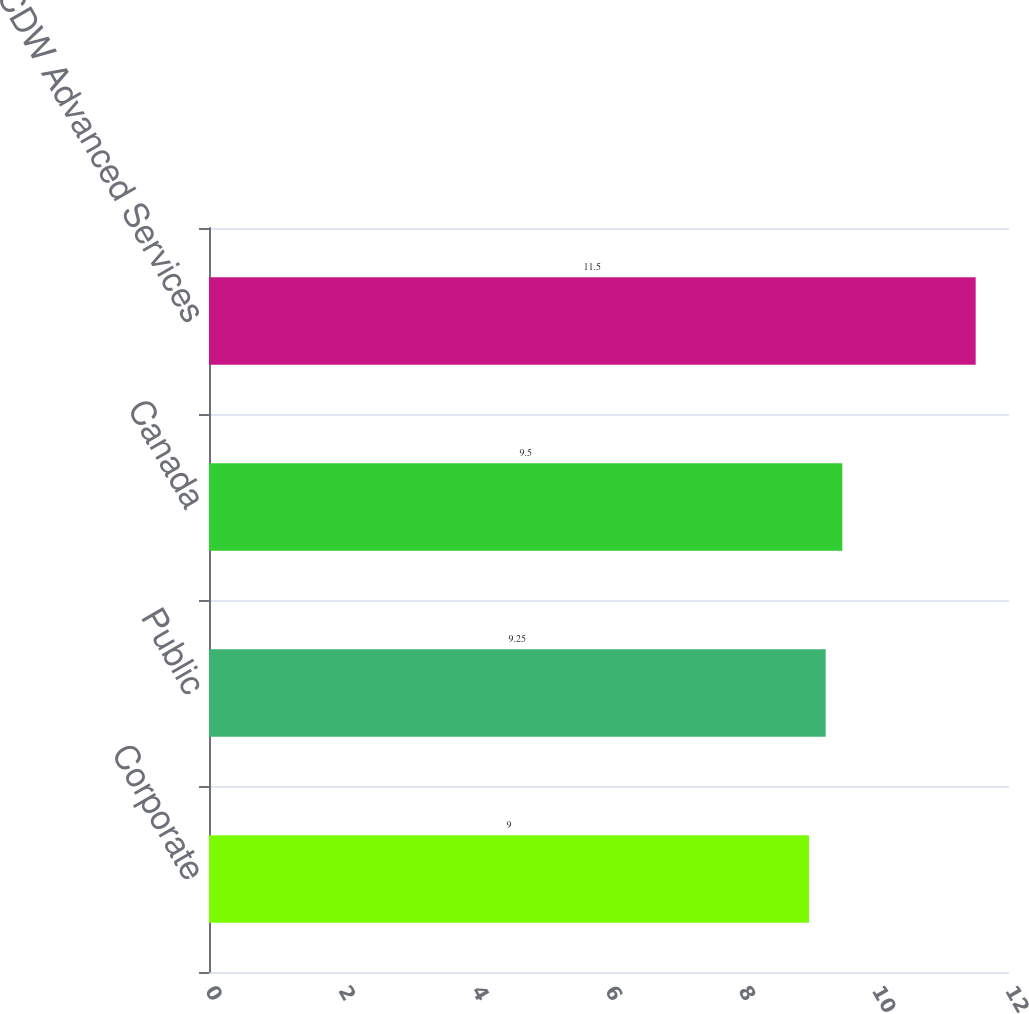Convert chart. <chart><loc_0><loc_0><loc_500><loc_500><bar_chart><fcel>Corporate<fcel>Public<fcel>Canada<fcel>CDW Advanced Services<nl><fcel>9<fcel>9.25<fcel>9.5<fcel>11.5<nl></chart> 